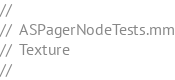<code> <loc_0><loc_0><loc_500><loc_500><_ObjectiveC_>//
//  ASPagerNodeTests.mm
//  Texture
//</code> 